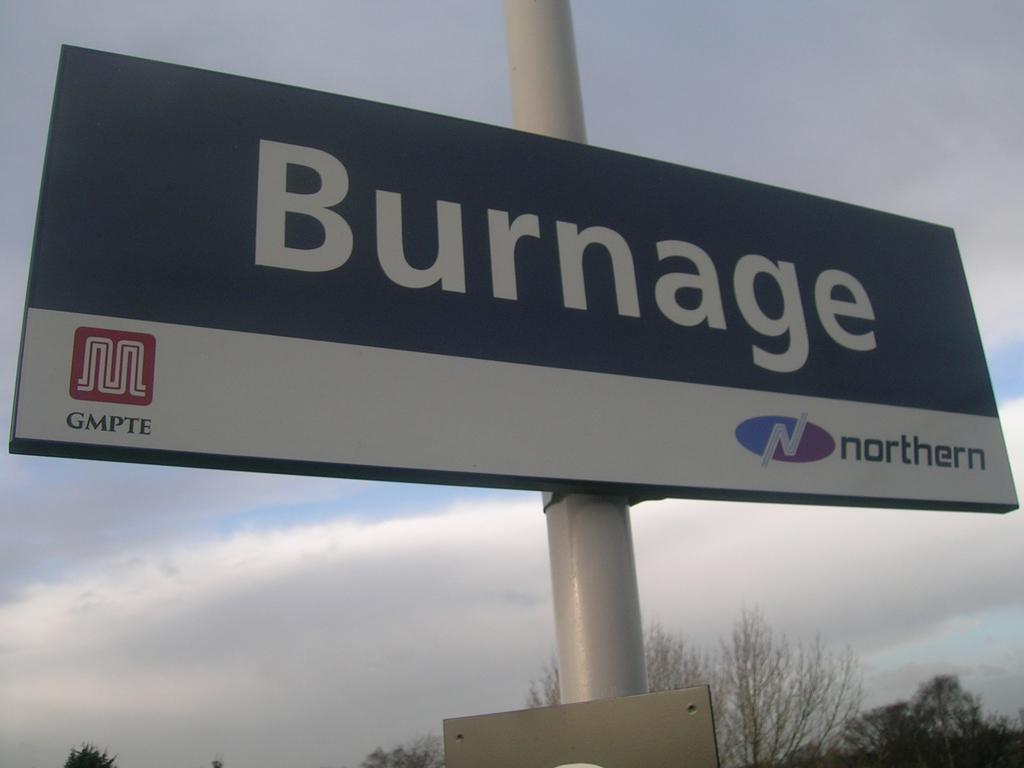<image>
Offer a succinct explanation of the picture presented. Big banner on a pole that says Burnage 